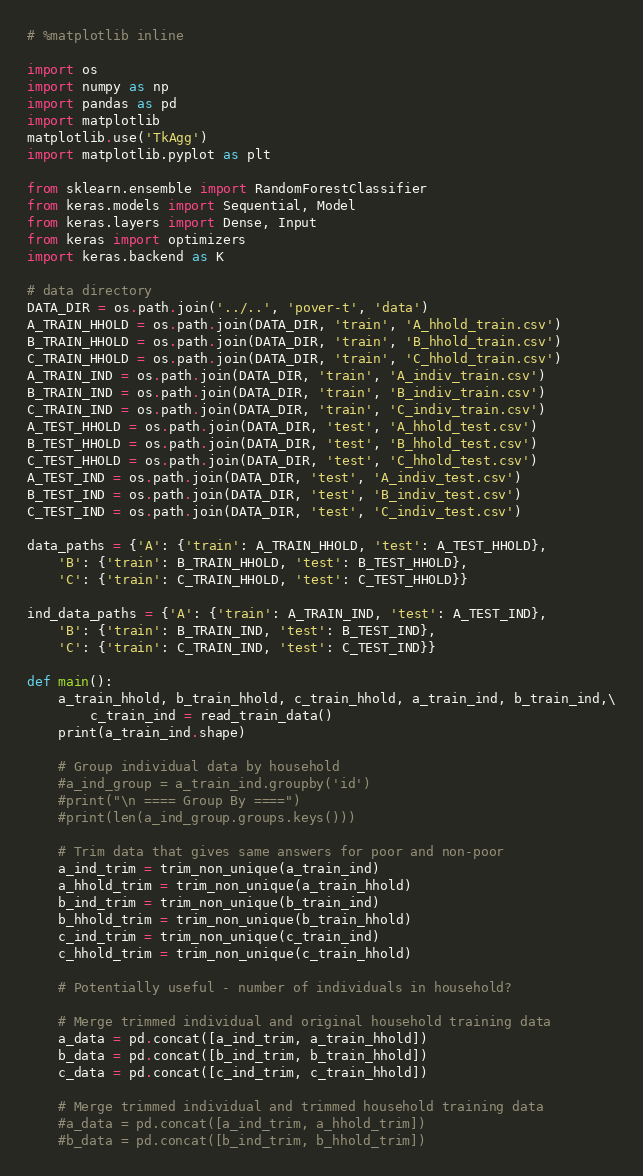Convert code to text. <code><loc_0><loc_0><loc_500><loc_500><_Python_># %matplotlib inline

import os
import numpy as np
import pandas as pd
import matplotlib
matplotlib.use('TkAgg')
import matplotlib.pyplot as plt

from sklearn.ensemble import RandomForestClassifier
from keras.models import Sequential, Model
from keras.layers import Dense, Input
from keras import optimizers
import keras.backend as K

# data directory
DATA_DIR = os.path.join('../..', 'pover-t', 'data')
A_TRAIN_HHOLD = os.path.join(DATA_DIR, 'train', 'A_hhold_train.csv')
B_TRAIN_HHOLD = os.path.join(DATA_DIR, 'train', 'B_hhold_train.csv')
C_TRAIN_HHOLD = os.path.join(DATA_DIR, 'train', 'C_hhold_train.csv')
A_TRAIN_IND = os.path.join(DATA_DIR, 'train', 'A_indiv_train.csv')
B_TRAIN_IND = os.path.join(DATA_DIR, 'train', 'B_indiv_train.csv')
C_TRAIN_IND = os.path.join(DATA_DIR, 'train', 'C_indiv_train.csv')
A_TEST_HHOLD = os.path.join(DATA_DIR, 'test', 'A_hhold_test.csv')
B_TEST_HHOLD = os.path.join(DATA_DIR, 'test', 'B_hhold_test.csv')
C_TEST_HHOLD = os.path.join(DATA_DIR, 'test', 'C_hhold_test.csv')
A_TEST_IND = os.path.join(DATA_DIR, 'test', 'A_indiv_test.csv')
B_TEST_IND = os.path.join(DATA_DIR, 'test', 'B_indiv_test.csv')
C_TEST_IND = os.path.join(DATA_DIR, 'test', 'C_indiv_test.csv')

data_paths = {'A': {'train': A_TRAIN_HHOLD, 'test': A_TEST_HHOLD},
    'B': {'train': B_TRAIN_HHOLD, 'test': B_TEST_HHOLD},
    'C': {'train': C_TRAIN_HHOLD, 'test': C_TEST_HHOLD}}

ind_data_paths = {'A': {'train': A_TRAIN_IND, 'test': A_TEST_IND},
    'B': {'train': B_TRAIN_IND, 'test': B_TEST_IND},
    'C': {'train': C_TRAIN_IND, 'test': C_TEST_IND}}

def main():
    a_train_hhold, b_train_hhold, c_train_hhold, a_train_ind, b_train_ind,\
        c_train_ind = read_train_data()
    print(a_train_ind.shape)

    # Group individual data by household
    #a_ind_group = a_train_ind.groupby('id')
    #print("\n ==== Group By ====")
    #print(len(a_ind_group.groups.keys()))

    # Trim data that gives same answers for poor and non-poor
    a_ind_trim = trim_non_unique(a_train_ind)
    a_hhold_trim = trim_non_unique(a_train_hhold)
    b_ind_trim = trim_non_unique(b_train_ind)
    b_hhold_trim = trim_non_unique(b_train_hhold)
    c_ind_trim = trim_non_unique(c_train_ind)
    c_hhold_trim = trim_non_unique(c_train_hhold)

    # Potentially useful - number of individuals in household?

    # Merge trimmed individual and original household training data
    a_data = pd.concat([a_ind_trim, a_train_hhold])
    b_data = pd.concat([b_ind_trim, b_train_hhold])
    c_data = pd.concat([c_ind_trim, c_train_hhold])

    # Merge trimmed individual and trimmed household training data
    #a_data = pd.concat([a_ind_trim, a_hhold_trim])
    #b_data = pd.concat([b_ind_trim, b_hhold_trim])</code> 